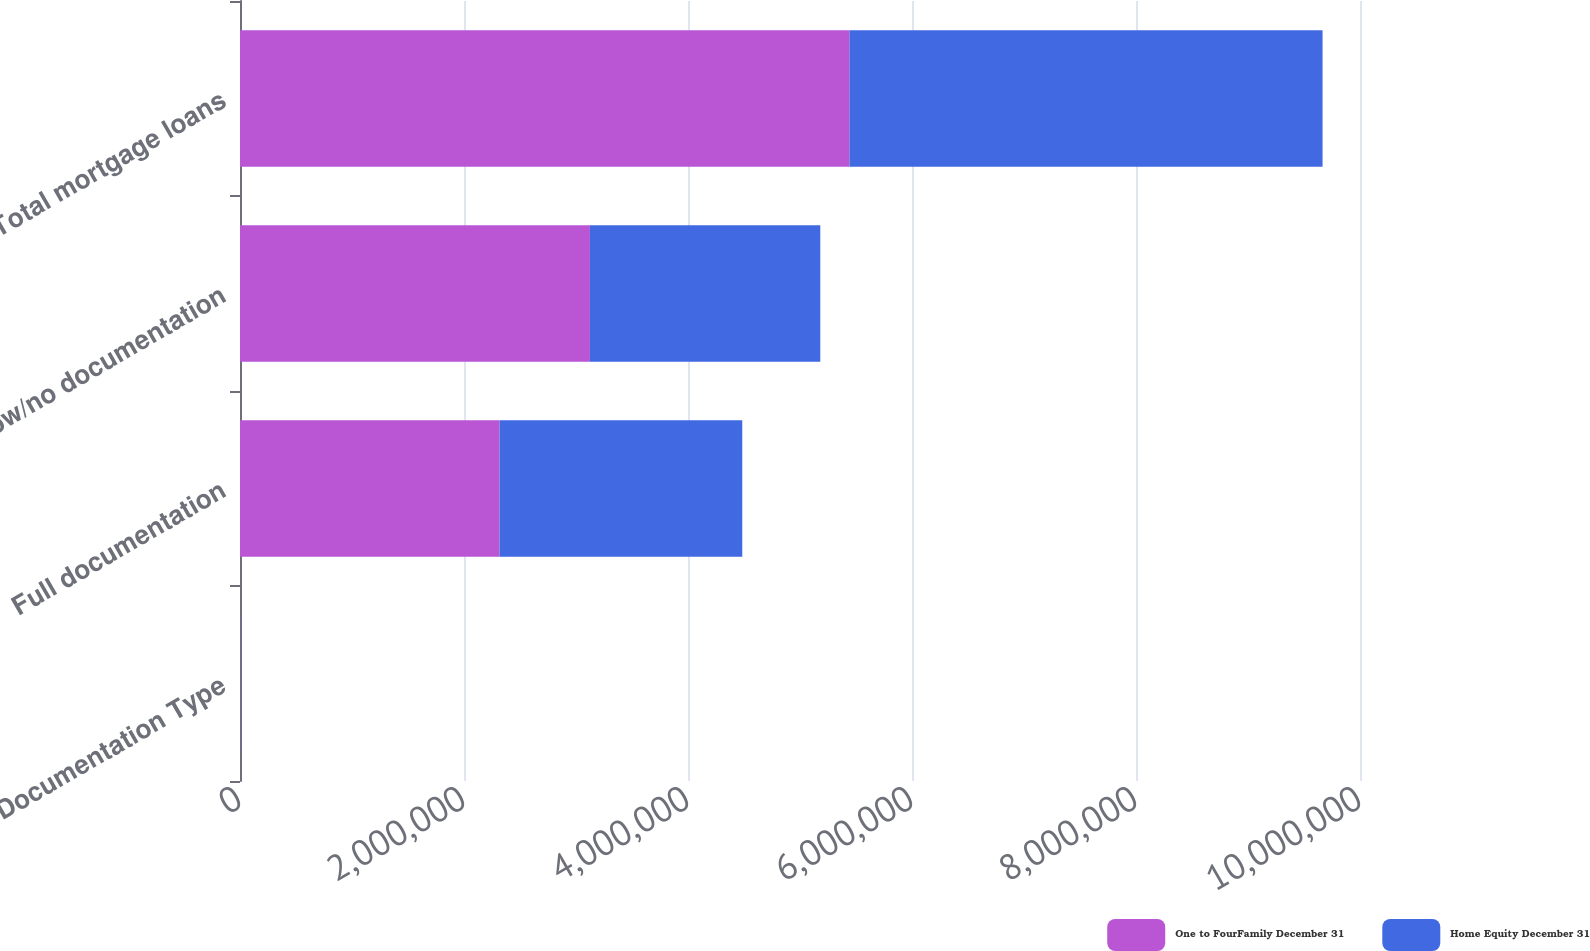<chart> <loc_0><loc_0><loc_500><loc_500><stacked_bar_chart><ecel><fcel>Documentation Type<fcel>Full documentation<fcel>Low/no documentation<fcel>Total mortgage loans<nl><fcel>One to FourFamily December 31<fcel>2012<fcel>2.31793e+06<fcel>3.12424e+06<fcel>5.44217e+06<nl><fcel>Home Equity December 31<fcel>2012<fcel>2.16655e+06<fcel>2.05691e+06<fcel>4.22346e+06<nl></chart> 